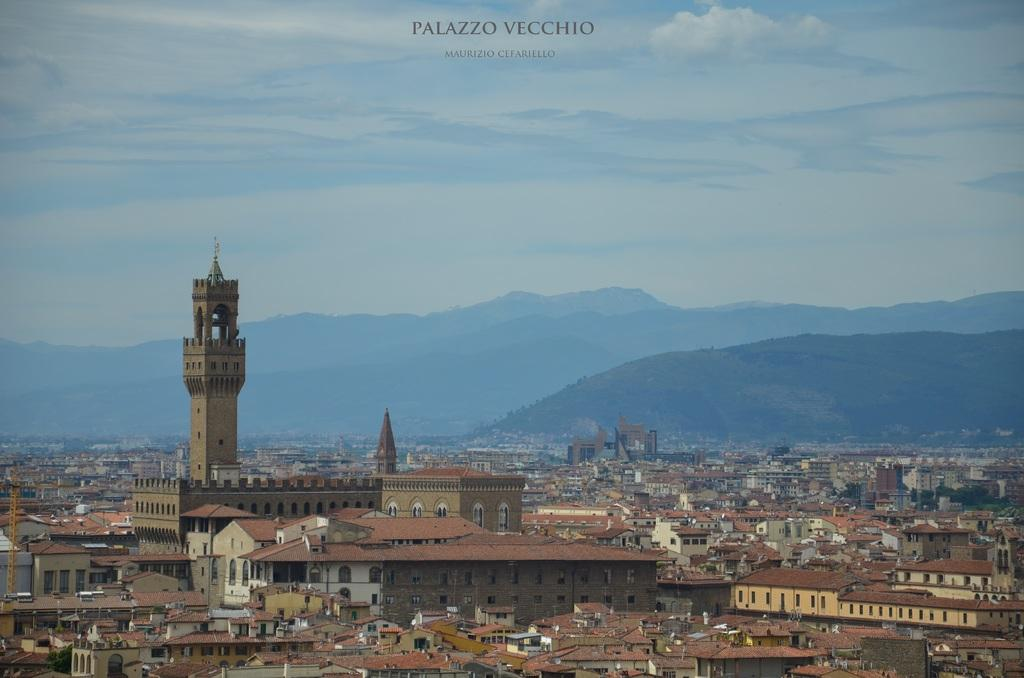What type of structures can be seen in the image? There are buildings in the image. Where is the tower located in the image? The tower is on the left side of the image. What can be seen in the distance in the image? There are hills visible in the background of the image. What is visible above the buildings in the image? The sky is visible in the image. What can be observed in the sky? There are clouds in the sky. What is written at the top of the image? There is some text at the top of the image. What type of calculator is being used for dinner in the image? There is no calculator or dinner present in the image. What company is responsible for the construction of the buildings in the image? The image does not provide information about the company responsible for the construction of the buildings. 